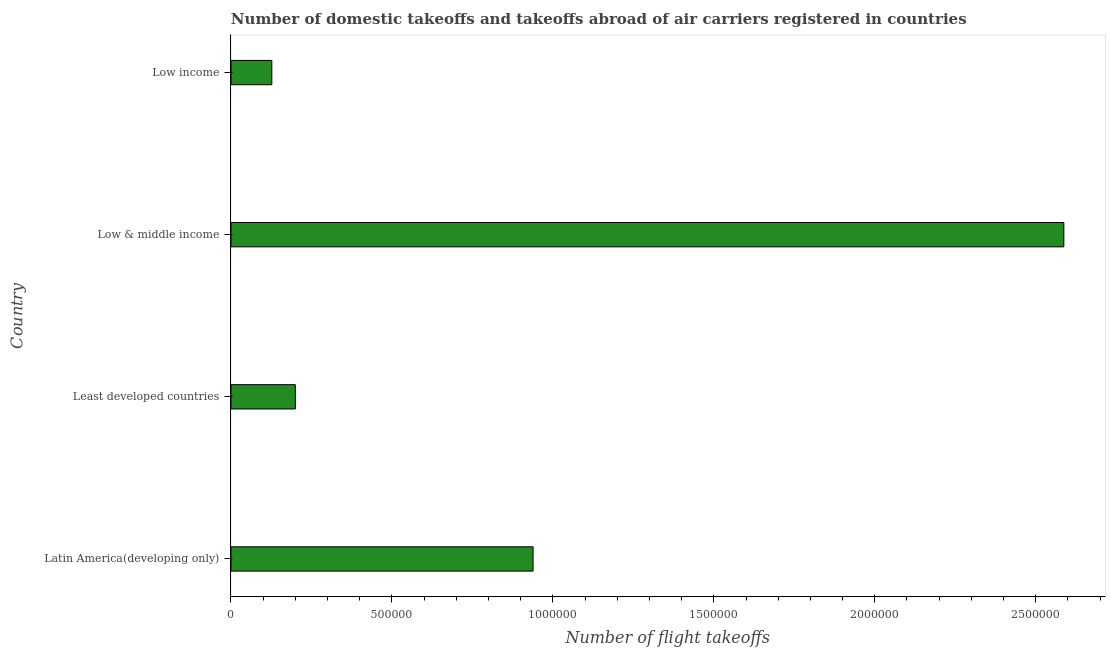Does the graph contain grids?
Make the answer very short. No. What is the title of the graph?
Provide a succinct answer. Number of domestic takeoffs and takeoffs abroad of air carriers registered in countries. What is the label or title of the X-axis?
Give a very brief answer. Number of flight takeoffs. What is the label or title of the Y-axis?
Offer a very short reply. Country. What is the number of flight takeoffs in Low income?
Provide a succinct answer. 1.27e+05. Across all countries, what is the maximum number of flight takeoffs?
Offer a terse response. 2.59e+06. Across all countries, what is the minimum number of flight takeoffs?
Offer a terse response. 1.27e+05. In which country was the number of flight takeoffs minimum?
Ensure brevity in your answer.  Low income. What is the sum of the number of flight takeoffs?
Your response must be concise. 3.85e+06. What is the difference between the number of flight takeoffs in Least developed countries and Low income?
Ensure brevity in your answer.  7.31e+04. What is the average number of flight takeoffs per country?
Keep it short and to the point. 9.63e+05. What is the median number of flight takeoffs?
Ensure brevity in your answer.  5.69e+05. In how many countries, is the number of flight takeoffs greater than 1700000 ?
Provide a short and direct response. 1. What is the ratio of the number of flight takeoffs in Latin America(developing only) to that in Low & middle income?
Keep it short and to the point. 0.36. What is the difference between the highest and the second highest number of flight takeoffs?
Your answer should be compact. 1.65e+06. Is the sum of the number of flight takeoffs in Latin America(developing only) and Least developed countries greater than the maximum number of flight takeoffs across all countries?
Provide a succinct answer. No. What is the difference between the highest and the lowest number of flight takeoffs?
Offer a terse response. 2.46e+06. Are all the bars in the graph horizontal?
Keep it short and to the point. Yes. How many countries are there in the graph?
Provide a short and direct response. 4. What is the Number of flight takeoffs of Latin America(developing only)?
Your answer should be very brief. 9.38e+05. What is the Number of flight takeoffs of Least developed countries?
Offer a very short reply. 2.00e+05. What is the Number of flight takeoffs of Low & middle income?
Your response must be concise. 2.59e+06. What is the Number of flight takeoffs of Low income?
Offer a terse response. 1.27e+05. What is the difference between the Number of flight takeoffs in Latin America(developing only) and Least developed countries?
Give a very brief answer. 7.38e+05. What is the difference between the Number of flight takeoffs in Latin America(developing only) and Low & middle income?
Offer a very short reply. -1.65e+06. What is the difference between the Number of flight takeoffs in Latin America(developing only) and Low income?
Your answer should be very brief. 8.12e+05. What is the difference between the Number of flight takeoffs in Least developed countries and Low & middle income?
Provide a succinct answer. -2.39e+06. What is the difference between the Number of flight takeoffs in Least developed countries and Low income?
Offer a very short reply. 7.31e+04. What is the difference between the Number of flight takeoffs in Low & middle income and Low income?
Your answer should be compact. 2.46e+06. What is the ratio of the Number of flight takeoffs in Latin America(developing only) to that in Least developed countries?
Ensure brevity in your answer.  4.69. What is the ratio of the Number of flight takeoffs in Latin America(developing only) to that in Low & middle income?
Make the answer very short. 0.36. What is the ratio of the Number of flight takeoffs in Latin America(developing only) to that in Low income?
Provide a short and direct response. 7.4. What is the ratio of the Number of flight takeoffs in Least developed countries to that in Low & middle income?
Provide a succinct answer. 0.08. What is the ratio of the Number of flight takeoffs in Least developed countries to that in Low income?
Give a very brief answer. 1.58. What is the ratio of the Number of flight takeoffs in Low & middle income to that in Low income?
Provide a succinct answer. 20.39. 